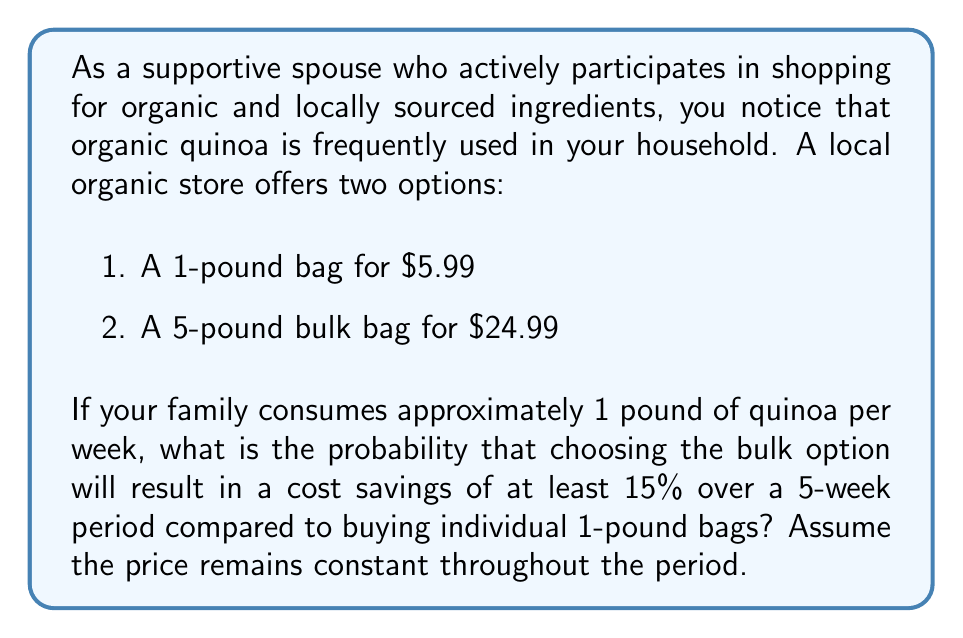Provide a solution to this math problem. To solve this problem, we need to follow these steps:

1. Calculate the cost of buying 5 individual 1-pound bags:
   $5.99 \times 5 = $29.95$

2. Calculate the cost of buying one 5-pound bulk bag:
   $24.99$

3. Calculate the actual savings:
   $29.95 - $24.99 = $4.96$

4. Calculate 15% of the cost of buying individual bags:
   $15\% \times $29.95 = 0.15 \times $29.95 = $4.4925$

5. Compare the actual savings to the 15% threshold:
   $4.96 > $4.4925$

Since the actual savings ($4.96) is greater than the 15% threshold ($4.4925), we can conclude that choosing the bulk option will always result in a cost savings of at least 15% over a 5-week period.

The probability of achieving at least a 15% cost savings is therefore 1 (or 100%), as it is a certainty.

This can be expressed mathematically as:

$$P(\text{Savings} \geq 15\%) = 1$$

In this case, there is no variability or uncertainty in the outcome, so the probability is simply 1.
Answer: The probability that choosing the bulk option will result in a cost savings of at least 15% over a 5-week period is 1 (or 100%). 